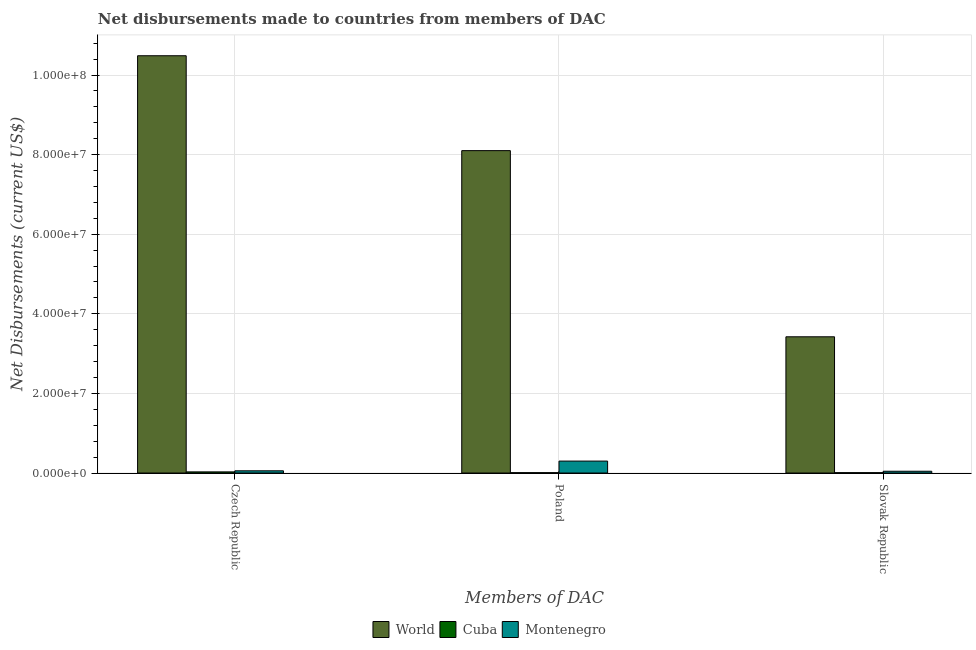How many different coloured bars are there?
Your answer should be compact. 3. How many groups of bars are there?
Your answer should be very brief. 3. Are the number of bars per tick equal to the number of legend labels?
Give a very brief answer. Yes. How many bars are there on the 3rd tick from the right?
Offer a terse response. 3. What is the label of the 2nd group of bars from the left?
Provide a short and direct response. Poland. What is the net disbursements made by slovak republic in Cuba?
Your answer should be compact. 9.00e+04. Across all countries, what is the maximum net disbursements made by slovak republic?
Give a very brief answer. 3.42e+07. Across all countries, what is the minimum net disbursements made by slovak republic?
Your answer should be very brief. 9.00e+04. In which country was the net disbursements made by slovak republic maximum?
Your response must be concise. World. In which country was the net disbursements made by slovak republic minimum?
Provide a short and direct response. Cuba. What is the total net disbursements made by slovak republic in the graph?
Give a very brief answer. 3.48e+07. What is the difference between the net disbursements made by poland in Cuba and that in World?
Provide a succinct answer. -8.09e+07. What is the difference between the net disbursements made by slovak republic in World and the net disbursements made by czech republic in Montenegro?
Keep it short and to the point. 3.37e+07. What is the average net disbursements made by poland per country?
Offer a very short reply. 2.80e+07. What is the difference between the net disbursements made by slovak republic and net disbursements made by czech republic in Montenegro?
Keep it short and to the point. -1.10e+05. What is the ratio of the net disbursements made by poland in World to that in Cuba?
Provide a succinct answer. 900. Is the net disbursements made by czech republic in Cuba less than that in World?
Provide a short and direct response. Yes. Is the difference between the net disbursements made by czech republic in World and Cuba greater than the difference between the net disbursements made by poland in World and Cuba?
Offer a terse response. Yes. What is the difference between the highest and the second highest net disbursements made by czech republic?
Your answer should be very brief. 1.04e+08. What is the difference between the highest and the lowest net disbursements made by slovak republic?
Make the answer very short. 3.41e+07. In how many countries, is the net disbursements made by slovak republic greater than the average net disbursements made by slovak republic taken over all countries?
Your response must be concise. 1. What does the 1st bar from the right in Slovak Republic represents?
Your answer should be very brief. Montenegro. Are all the bars in the graph horizontal?
Make the answer very short. No. What is the difference between two consecutive major ticks on the Y-axis?
Your answer should be very brief. 2.00e+07. Are the values on the major ticks of Y-axis written in scientific E-notation?
Provide a succinct answer. Yes. Does the graph contain any zero values?
Your answer should be compact. No. Where does the legend appear in the graph?
Give a very brief answer. Bottom center. How are the legend labels stacked?
Make the answer very short. Horizontal. What is the title of the graph?
Your response must be concise. Net disbursements made to countries from members of DAC. What is the label or title of the X-axis?
Provide a short and direct response. Members of DAC. What is the label or title of the Y-axis?
Offer a terse response. Net Disbursements (current US$). What is the Net Disbursements (current US$) of World in Czech Republic?
Keep it short and to the point. 1.05e+08. What is the Net Disbursements (current US$) of Cuba in Czech Republic?
Your answer should be very brief. 2.90e+05. What is the Net Disbursements (current US$) of Montenegro in Czech Republic?
Give a very brief answer. 5.60e+05. What is the Net Disbursements (current US$) of World in Poland?
Give a very brief answer. 8.10e+07. What is the Net Disbursements (current US$) of Cuba in Poland?
Offer a very short reply. 9.00e+04. What is the Net Disbursements (current US$) of Montenegro in Poland?
Keep it short and to the point. 3.00e+06. What is the Net Disbursements (current US$) of World in Slovak Republic?
Your response must be concise. 3.42e+07. What is the Net Disbursements (current US$) in Cuba in Slovak Republic?
Your answer should be compact. 9.00e+04. What is the Net Disbursements (current US$) of Montenegro in Slovak Republic?
Give a very brief answer. 4.50e+05. Across all Members of DAC, what is the maximum Net Disbursements (current US$) of World?
Offer a terse response. 1.05e+08. Across all Members of DAC, what is the maximum Net Disbursements (current US$) of Montenegro?
Your response must be concise. 3.00e+06. Across all Members of DAC, what is the minimum Net Disbursements (current US$) in World?
Offer a terse response. 3.42e+07. Across all Members of DAC, what is the minimum Net Disbursements (current US$) of Cuba?
Provide a short and direct response. 9.00e+04. What is the total Net Disbursements (current US$) of World in the graph?
Your answer should be very brief. 2.20e+08. What is the total Net Disbursements (current US$) of Montenegro in the graph?
Give a very brief answer. 4.01e+06. What is the difference between the Net Disbursements (current US$) of World in Czech Republic and that in Poland?
Make the answer very short. 2.38e+07. What is the difference between the Net Disbursements (current US$) in Montenegro in Czech Republic and that in Poland?
Ensure brevity in your answer.  -2.44e+06. What is the difference between the Net Disbursements (current US$) of World in Czech Republic and that in Slovak Republic?
Your response must be concise. 7.06e+07. What is the difference between the Net Disbursements (current US$) of Cuba in Czech Republic and that in Slovak Republic?
Provide a succinct answer. 2.00e+05. What is the difference between the Net Disbursements (current US$) of World in Poland and that in Slovak Republic?
Provide a succinct answer. 4.68e+07. What is the difference between the Net Disbursements (current US$) of Cuba in Poland and that in Slovak Republic?
Give a very brief answer. 0. What is the difference between the Net Disbursements (current US$) in Montenegro in Poland and that in Slovak Republic?
Your answer should be very brief. 2.55e+06. What is the difference between the Net Disbursements (current US$) of World in Czech Republic and the Net Disbursements (current US$) of Cuba in Poland?
Make the answer very short. 1.05e+08. What is the difference between the Net Disbursements (current US$) of World in Czech Republic and the Net Disbursements (current US$) of Montenegro in Poland?
Make the answer very short. 1.02e+08. What is the difference between the Net Disbursements (current US$) of Cuba in Czech Republic and the Net Disbursements (current US$) of Montenegro in Poland?
Provide a short and direct response. -2.71e+06. What is the difference between the Net Disbursements (current US$) in World in Czech Republic and the Net Disbursements (current US$) in Cuba in Slovak Republic?
Give a very brief answer. 1.05e+08. What is the difference between the Net Disbursements (current US$) in World in Czech Republic and the Net Disbursements (current US$) in Montenegro in Slovak Republic?
Ensure brevity in your answer.  1.04e+08. What is the difference between the Net Disbursements (current US$) in World in Poland and the Net Disbursements (current US$) in Cuba in Slovak Republic?
Your answer should be very brief. 8.09e+07. What is the difference between the Net Disbursements (current US$) of World in Poland and the Net Disbursements (current US$) of Montenegro in Slovak Republic?
Provide a succinct answer. 8.06e+07. What is the difference between the Net Disbursements (current US$) in Cuba in Poland and the Net Disbursements (current US$) in Montenegro in Slovak Republic?
Provide a short and direct response. -3.60e+05. What is the average Net Disbursements (current US$) in World per Members of DAC?
Keep it short and to the point. 7.34e+07. What is the average Net Disbursements (current US$) of Cuba per Members of DAC?
Make the answer very short. 1.57e+05. What is the average Net Disbursements (current US$) in Montenegro per Members of DAC?
Keep it short and to the point. 1.34e+06. What is the difference between the Net Disbursements (current US$) in World and Net Disbursements (current US$) in Cuba in Czech Republic?
Keep it short and to the point. 1.05e+08. What is the difference between the Net Disbursements (current US$) of World and Net Disbursements (current US$) of Montenegro in Czech Republic?
Offer a terse response. 1.04e+08. What is the difference between the Net Disbursements (current US$) of Cuba and Net Disbursements (current US$) of Montenegro in Czech Republic?
Ensure brevity in your answer.  -2.70e+05. What is the difference between the Net Disbursements (current US$) of World and Net Disbursements (current US$) of Cuba in Poland?
Your answer should be very brief. 8.09e+07. What is the difference between the Net Disbursements (current US$) of World and Net Disbursements (current US$) of Montenegro in Poland?
Ensure brevity in your answer.  7.80e+07. What is the difference between the Net Disbursements (current US$) in Cuba and Net Disbursements (current US$) in Montenegro in Poland?
Offer a terse response. -2.91e+06. What is the difference between the Net Disbursements (current US$) in World and Net Disbursements (current US$) in Cuba in Slovak Republic?
Give a very brief answer. 3.41e+07. What is the difference between the Net Disbursements (current US$) in World and Net Disbursements (current US$) in Montenegro in Slovak Republic?
Your answer should be compact. 3.38e+07. What is the difference between the Net Disbursements (current US$) of Cuba and Net Disbursements (current US$) of Montenegro in Slovak Republic?
Your answer should be compact. -3.60e+05. What is the ratio of the Net Disbursements (current US$) in World in Czech Republic to that in Poland?
Keep it short and to the point. 1.29. What is the ratio of the Net Disbursements (current US$) of Cuba in Czech Republic to that in Poland?
Make the answer very short. 3.22. What is the ratio of the Net Disbursements (current US$) of Montenegro in Czech Republic to that in Poland?
Provide a succinct answer. 0.19. What is the ratio of the Net Disbursements (current US$) of World in Czech Republic to that in Slovak Republic?
Offer a terse response. 3.06. What is the ratio of the Net Disbursements (current US$) in Cuba in Czech Republic to that in Slovak Republic?
Offer a very short reply. 3.22. What is the ratio of the Net Disbursements (current US$) of Montenegro in Czech Republic to that in Slovak Republic?
Give a very brief answer. 1.24. What is the ratio of the Net Disbursements (current US$) of World in Poland to that in Slovak Republic?
Your answer should be compact. 2.37. What is the ratio of the Net Disbursements (current US$) of Montenegro in Poland to that in Slovak Republic?
Offer a very short reply. 6.67. What is the difference between the highest and the second highest Net Disbursements (current US$) of World?
Make the answer very short. 2.38e+07. What is the difference between the highest and the second highest Net Disbursements (current US$) in Cuba?
Provide a succinct answer. 2.00e+05. What is the difference between the highest and the second highest Net Disbursements (current US$) of Montenegro?
Your response must be concise. 2.44e+06. What is the difference between the highest and the lowest Net Disbursements (current US$) in World?
Offer a terse response. 7.06e+07. What is the difference between the highest and the lowest Net Disbursements (current US$) in Montenegro?
Offer a very short reply. 2.55e+06. 